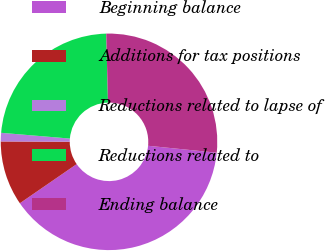Convert chart. <chart><loc_0><loc_0><loc_500><loc_500><pie_chart><fcel>Beginning balance<fcel>Additions for tax positions<fcel>Reductions related to lapse of<fcel>Reductions related to<fcel>Ending balance<nl><fcel>38.8%<fcel>9.66%<fcel>1.27%<fcel>23.26%<fcel>27.01%<nl></chart> 